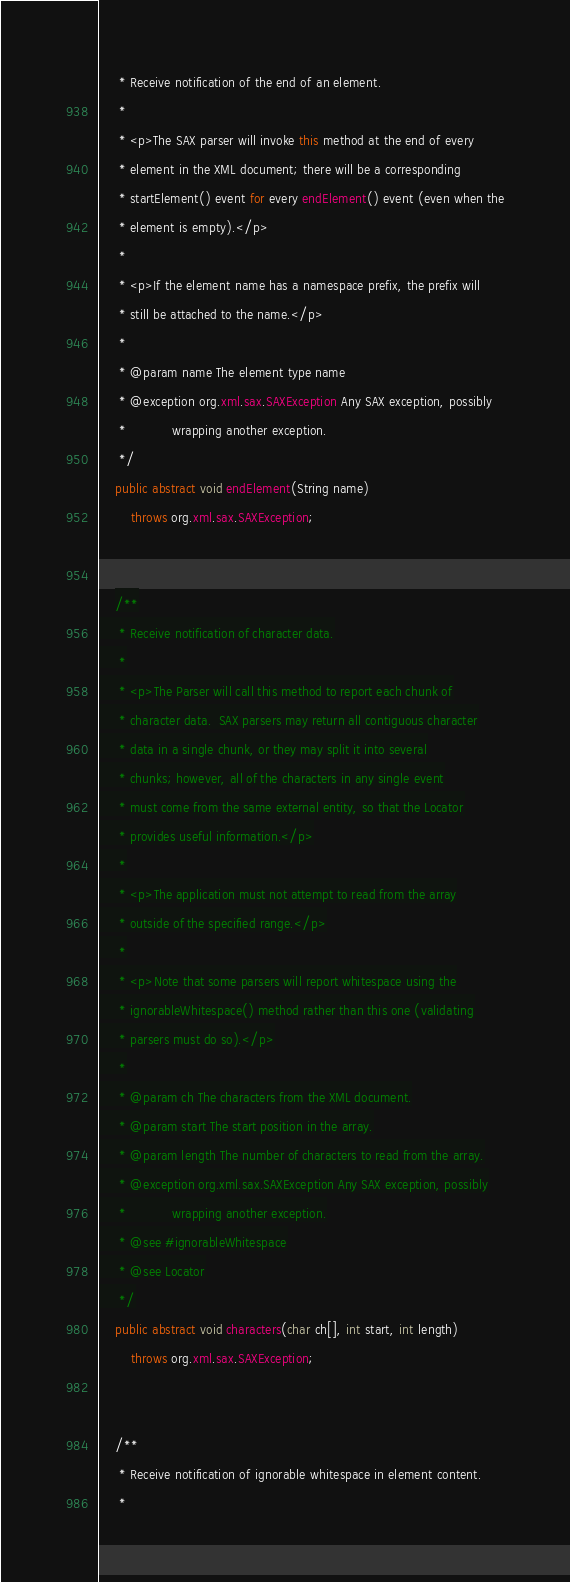<code> <loc_0><loc_0><loc_500><loc_500><_Java_>     * Receive notification of the end of an element.
     *
     * <p>The SAX parser will invoke this method at the end of every
     * element in the XML document; there will be a corresponding
     * startElement() event for every endElement() event (even when the
     * element is empty).</p>
     *
     * <p>If the element name has a namespace prefix, the prefix will
     * still be attached to the name.</p>
     *
     * @param name The element type name
     * @exception org.xml.sax.SAXException Any SAX exception, possibly
     *            wrapping another exception.
     */
    public abstract void endElement(String name)
        throws org.xml.sax.SAXException;


    /**
     * Receive notification of character data.
     *
     * <p>The Parser will call this method to report each chunk of
     * character data.  SAX parsers may return all contiguous character
     * data in a single chunk, or they may split it into several
     * chunks; however, all of the characters in any single event
     * must come from the same external entity, so that the Locator
     * provides useful information.</p>
     *
     * <p>The application must not attempt to read from the array
     * outside of the specified range.</p>
     *
     * <p>Note that some parsers will report whitespace using the
     * ignorableWhitespace() method rather than this one (validating
     * parsers must do so).</p>
     *
     * @param ch The characters from the XML document.
     * @param start The start position in the array.
     * @param length The number of characters to read from the array.
     * @exception org.xml.sax.SAXException Any SAX exception, possibly
     *            wrapping another exception.
     * @see #ignorableWhitespace
     * @see Locator
     */
    public abstract void characters(char ch[], int start, int length)
        throws org.xml.sax.SAXException;


    /**
     * Receive notification of ignorable whitespace in element content.
     *</code> 